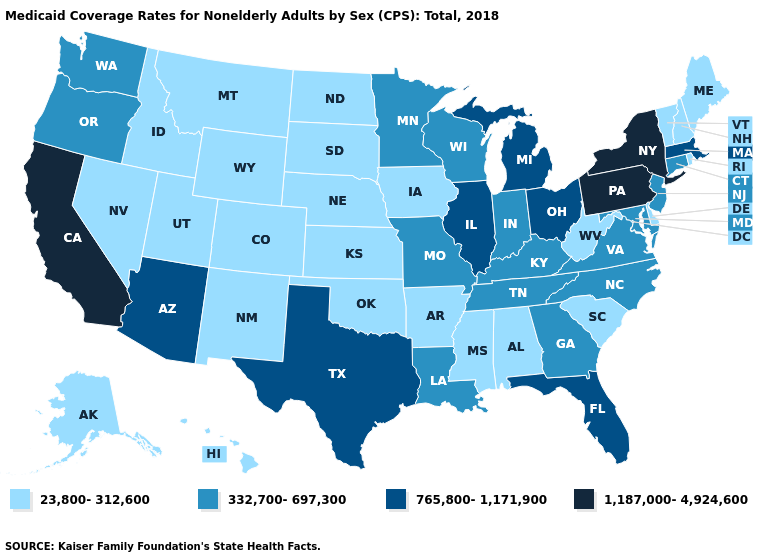What is the value of Alabama?
Write a very short answer. 23,800-312,600. What is the value of New York?
Keep it brief. 1,187,000-4,924,600. What is the highest value in the USA?
Quick response, please. 1,187,000-4,924,600. What is the value of Virginia?
Give a very brief answer. 332,700-697,300. Name the states that have a value in the range 332,700-697,300?
Quick response, please. Connecticut, Georgia, Indiana, Kentucky, Louisiana, Maryland, Minnesota, Missouri, New Jersey, North Carolina, Oregon, Tennessee, Virginia, Washington, Wisconsin. Among the states that border Michigan , does Ohio have the highest value?
Concise answer only. Yes. What is the lowest value in the USA?
Answer briefly. 23,800-312,600. Which states have the lowest value in the USA?
Quick response, please. Alabama, Alaska, Arkansas, Colorado, Delaware, Hawaii, Idaho, Iowa, Kansas, Maine, Mississippi, Montana, Nebraska, Nevada, New Hampshire, New Mexico, North Dakota, Oklahoma, Rhode Island, South Carolina, South Dakota, Utah, Vermont, West Virginia, Wyoming. Does New Hampshire have the lowest value in the Northeast?
Keep it brief. Yes. Name the states that have a value in the range 1,187,000-4,924,600?
Write a very short answer. California, New York, Pennsylvania. How many symbols are there in the legend?
Concise answer only. 4. Which states have the lowest value in the USA?
Concise answer only. Alabama, Alaska, Arkansas, Colorado, Delaware, Hawaii, Idaho, Iowa, Kansas, Maine, Mississippi, Montana, Nebraska, Nevada, New Hampshire, New Mexico, North Dakota, Oklahoma, Rhode Island, South Carolina, South Dakota, Utah, Vermont, West Virginia, Wyoming. How many symbols are there in the legend?
Give a very brief answer. 4. Which states have the lowest value in the USA?
Give a very brief answer. Alabama, Alaska, Arkansas, Colorado, Delaware, Hawaii, Idaho, Iowa, Kansas, Maine, Mississippi, Montana, Nebraska, Nevada, New Hampshire, New Mexico, North Dakota, Oklahoma, Rhode Island, South Carolina, South Dakota, Utah, Vermont, West Virginia, Wyoming. Name the states that have a value in the range 23,800-312,600?
Write a very short answer. Alabama, Alaska, Arkansas, Colorado, Delaware, Hawaii, Idaho, Iowa, Kansas, Maine, Mississippi, Montana, Nebraska, Nevada, New Hampshire, New Mexico, North Dakota, Oklahoma, Rhode Island, South Carolina, South Dakota, Utah, Vermont, West Virginia, Wyoming. 